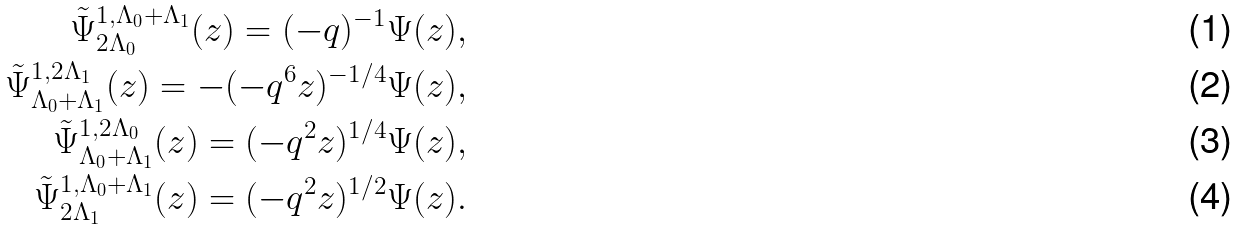Convert formula to latex. <formula><loc_0><loc_0><loc_500><loc_500>\tilde { \Psi } _ { 2 \Lambda _ { 0 } } ^ { 1 , \Lambda _ { 0 } + \Lambda _ { 1 } } ( z ) = ( - q ) ^ { - 1 } \Psi ( z ) , \\ \tilde { \Psi } ^ { 1 , 2 \Lambda _ { 1 } } _ { \Lambda _ { 0 } + \Lambda _ { 1 } } ( z ) = - ( - q ^ { 6 } z ) ^ { - 1 / 4 } \Psi ( z ) , \\ \tilde { \Psi } ^ { 1 , 2 \Lambda _ { 0 } } _ { \Lambda _ { 0 } + \Lambda _ { 1 } } ( z ) = ( - q ^ { 2 } z ) ^ { 1 / 4 } \Psi ( z ) , \\ \tilde { \Psi } _ { 2 \Lambda _ { 1 } } ^ { 1 , \Lambda _ { 0 } + \Lambda _ { 1 } } ( z ) = ( - q ^ { 2 } z ) ^ { 1 / 2 } \Psi ( z ) .</formula> 